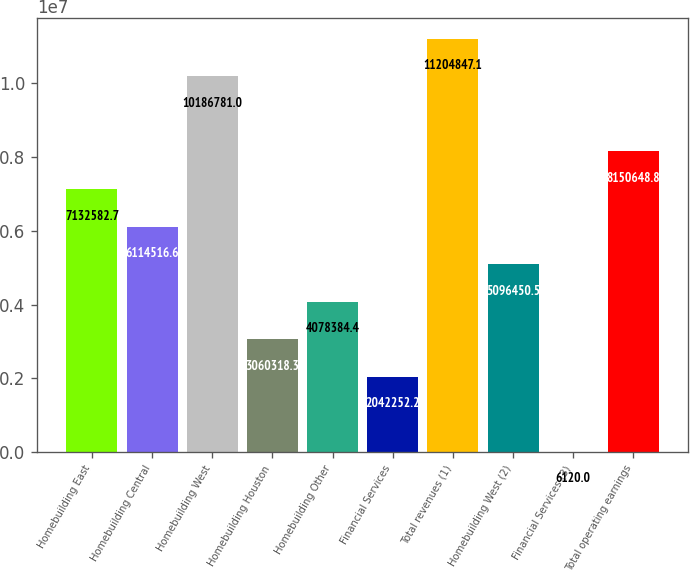Convert chart. <chart><loc_0><loc_0><loc_500><loc_500><bar_chart><fcel>Homebuilding East<fcel>Homebuilding Central<fcel>Homebuilding West<fcel>Homebuilding Houston<fcel>Homebuilding Other<fcel>Financial Services<fcel>Total revenues (1)<fcel>Homebuilding West (2)<fcel>Financial Services (3)<fcel>Total operating earnings<nl><fcel>7.13258e+06<fcel>6.11452e+06<fcel>1.01868e+07<fcel>3.06032e+06<fcel>4.07838e+06<fcel>2.04225e+06<fcel>1.12048e+07<fcel>5.09645e+06<fcel>6120<fcel>8.15065e+06<nl></chart> 